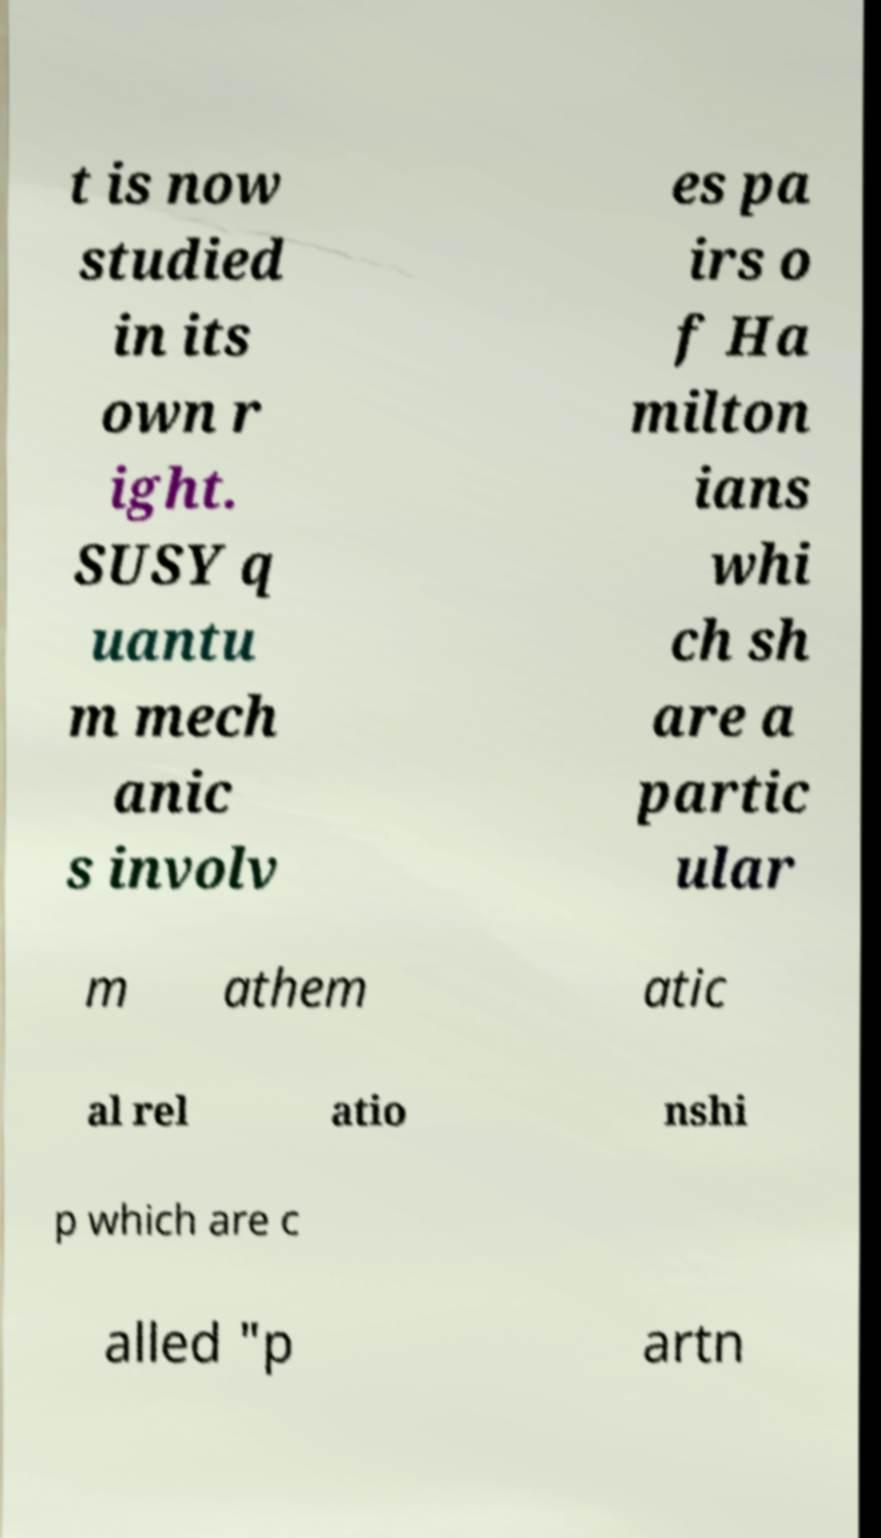Can you accurately transcribe the text from the provided image for me? t is now studied in its own r ight. SUSY q uantu m mech anic s involv es pa irs o f Ha milton ians whi ch sh are a partic ular m athem atic al rel atio nshi p which are c alled "p artn 